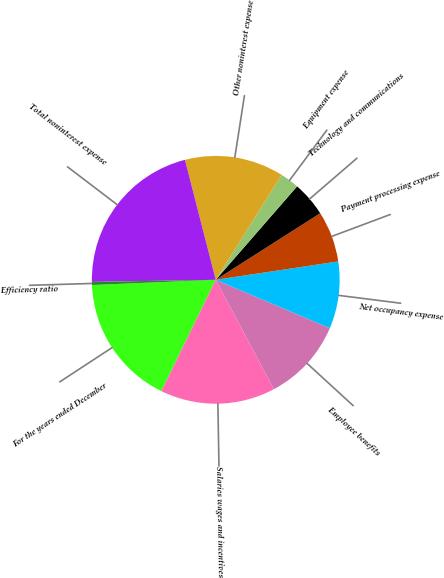Convert chart to OTSL. <chart><loc_0><loc_0><loc_500><loc_500><pie_chart><fcel>For the years ended December<fcel>Salaries wages and incentives<fcel>Employee benefits<fcel>Net occupancy expense<fcel>Payment processing expense<fcel>Technology and communications<fcel>Equipment expense<fcel>Other noninterest expense<fcel>Total noninterest expense<fcel>Efficiency ratio<nl><fcel>17.1%<fcel>15.01%<fcel>10.84%<fcel>8.75%<fcel>6.66%<fcel>4.57%<fcel>2.48%<fcel>12.92%<fcel>21.27%<fcel>0.4%<nl></chart> 